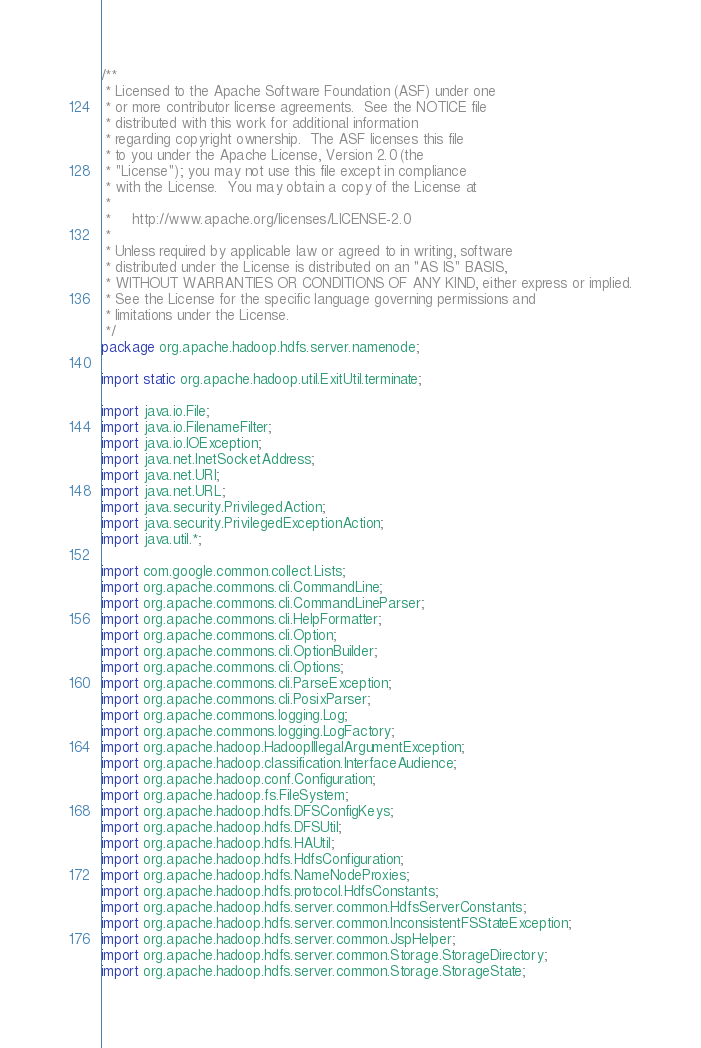Convert code to text. <code><loc_0><loc_0><loc_500><loc_500><_Java_>/**
 * Licensed to the Apache Software Foundation (ASF) under one
 * or more contributor license agreements.  See the NOTICE file
 * distributed with this work for additional information
 * regarding copyright ownership.  The ASF licenses this file
 * to you under the Apache License, Version 2.0 (the
 * "License"); you may not use this file except in compliance
 * with the License.  You may obtain a copy of the License at
 *
 *     http://www.apache.org/licenses/LICENSE-2.0
 *
 * Unless required by applicable law or agreed to in writing, software
 * distributed under the License is distributed on an "AS IS" BASIS,
 * WITHOUT WARRANTIES OR CONDITIONS OF ANY KIND, either express or implied.
 * See the License for the specific language governing permissions and
 * limitations under the License.
 */
package org.apache.hadoop.hdfs.server.namenode;

import static org.apache.hadoop.util.ExitUtil.terminate;

import java.io.File;
import java.io.FilenameFilter;
import java.io.IOException;
import java.net.InetSocketAddress;
import java.net.URI;
import java.net.URL;
import java.security.PrivilegedAction;
import java.security.PrivilegedExceptionAction;
import java.util.*;

import com.google.common.collect.Lists;
import org.apache.commons.cli.CommandLine;
import org.apache.commons.cli.CommandLineParser;
import org.apache.commons.cli.HelpFormatter;
import org.apache.commons.cli.Option;
import org.apache.commons.cli.OptionBuilder;
import org.apache.commons.cli.Options;
import org.apache.commons.cli.ParseException;
import org.apache.commons.cli.PosixParser;
import org.apache.commons.logging.Log;
import org.apache.commons.logging.LogFactory;
import org.apache.hadoop.HadoopIllegalArgumentException;
import org.apache.hadoop.classification.InterfaceAudience;
import org.apache.hadoop.conf.Configuration;
import org.apache.hadoop.fs.FileSystem;
import org.apache.hadoop.hdfs.DFSConfigKeys;
import org.apache.hadoop.hdfs.DFSUtil;
import org.apache.hadoop.hdfs.HAUtil;
import org.apache.hadoop.hdfs.HdfsConfiguration;
import org.apache.hadoop.hdfs.NameNodeProxies;
import org.apache.hadoop.hdfs.protocol.HdfsConstants;
import org.apache.hadoop.hdfs.server.common.HdfsServerConstants;
import org.apache.hadoop.hdfs.server.common.InconsistentFSStateException;
import org.apache.hadoop.hdfs.server.common.JspHelper;
import org.apache.hadoop.hdfs.server.common.Storage.StorageDirectory;
import org.apache.hadoop.hdfs.server.common.Storage.StorageState;</code> 